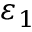<formula> <loc_0><loc_0><loc_500><loc_500>\varepsilon _ { 1 }</formula> 